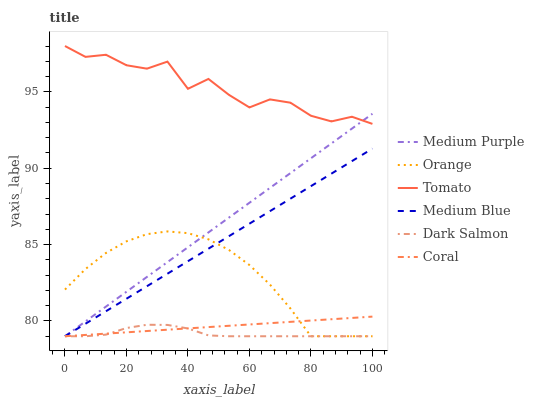Does Dark Salmon have the minimum area under the curve?
Answer yes or no. Yes. Does Tomato have the maximum area under the curve?
Answer yes or no. Yes. Does Coral have the minimum area under the curve?
Answer yes or no. No. Does Coral have the maximum area under the curve?
Answer yes or no. No. Is Medium Purple the smoothest?
Answer yes or no. Yes. Is Tomato the roughest?
Answer yes or no. Yes. Is Coral the smoothest?
Answer yes or no. No. Is Coral the roughest?
Answer yes or no. No. Does Coral have the lowest value?
Answer yes or no. Yes. Does Tomato have the highest value?
Answer yes or no. Yes. Does Coral have the highest value?
Answer yes or no. No. Is Orange less than Tomato?
Answer yes or no. Yes. Is Tomato greater than Coral?
Answer yes or no. Yes. Does Tomato intersect Medium Purple?
Answer yes or no. Yes. Is Tomato less than Medium Purple?
Answer yes or no. No. Is Tomato greater than Medium Purple?
Answer yes or no. No. Does Orange intersect Tomato?
Answer yes or no. No. 